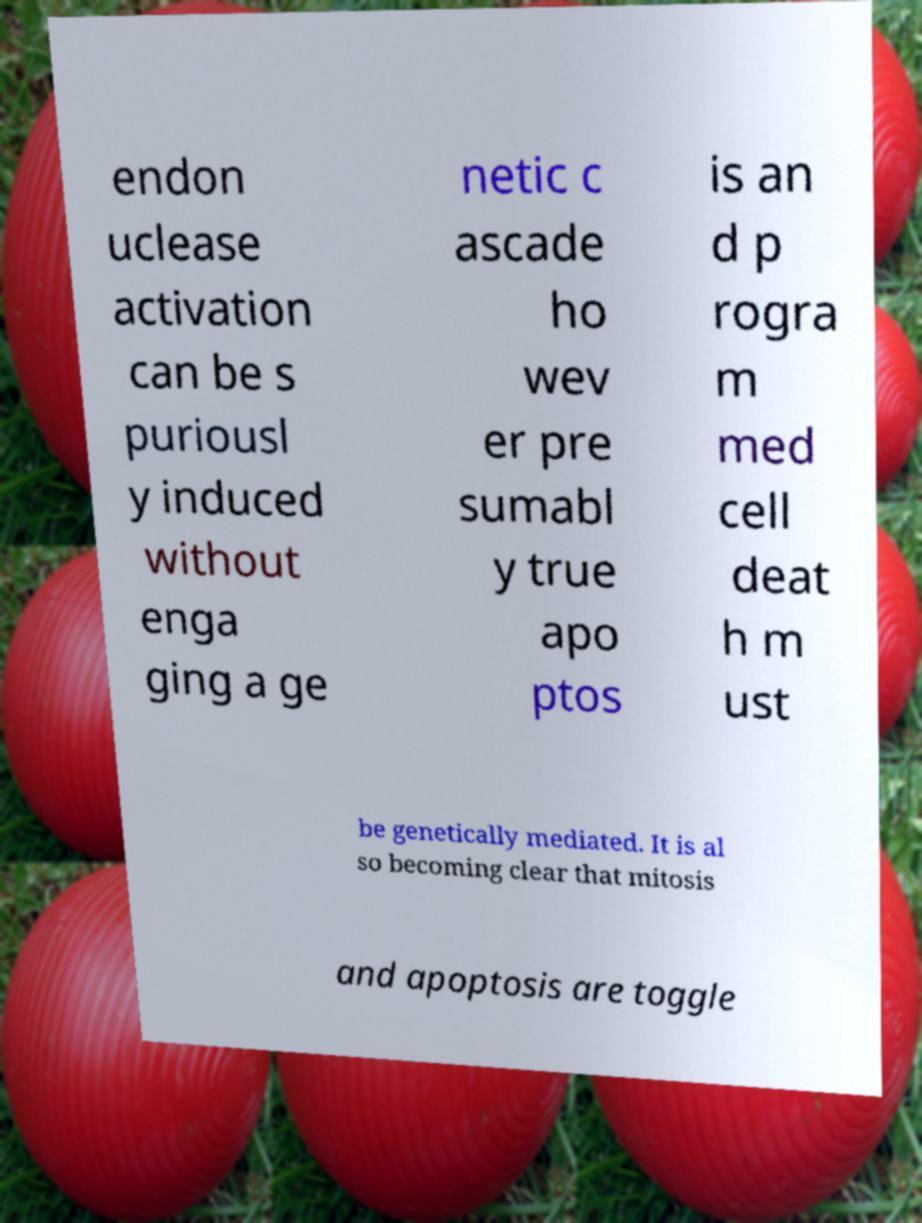Please read and relay the text visible in this image. What does it say? endon uclease activation can be s puriousl y induced without enga ging a ge netic c ascade ho wev er pre sumabl y true apo ptos is an d p rogra m med cell deat h m ust be genetically mediated. It is al so becoming clear that mitosis and apoptosis are toggle 